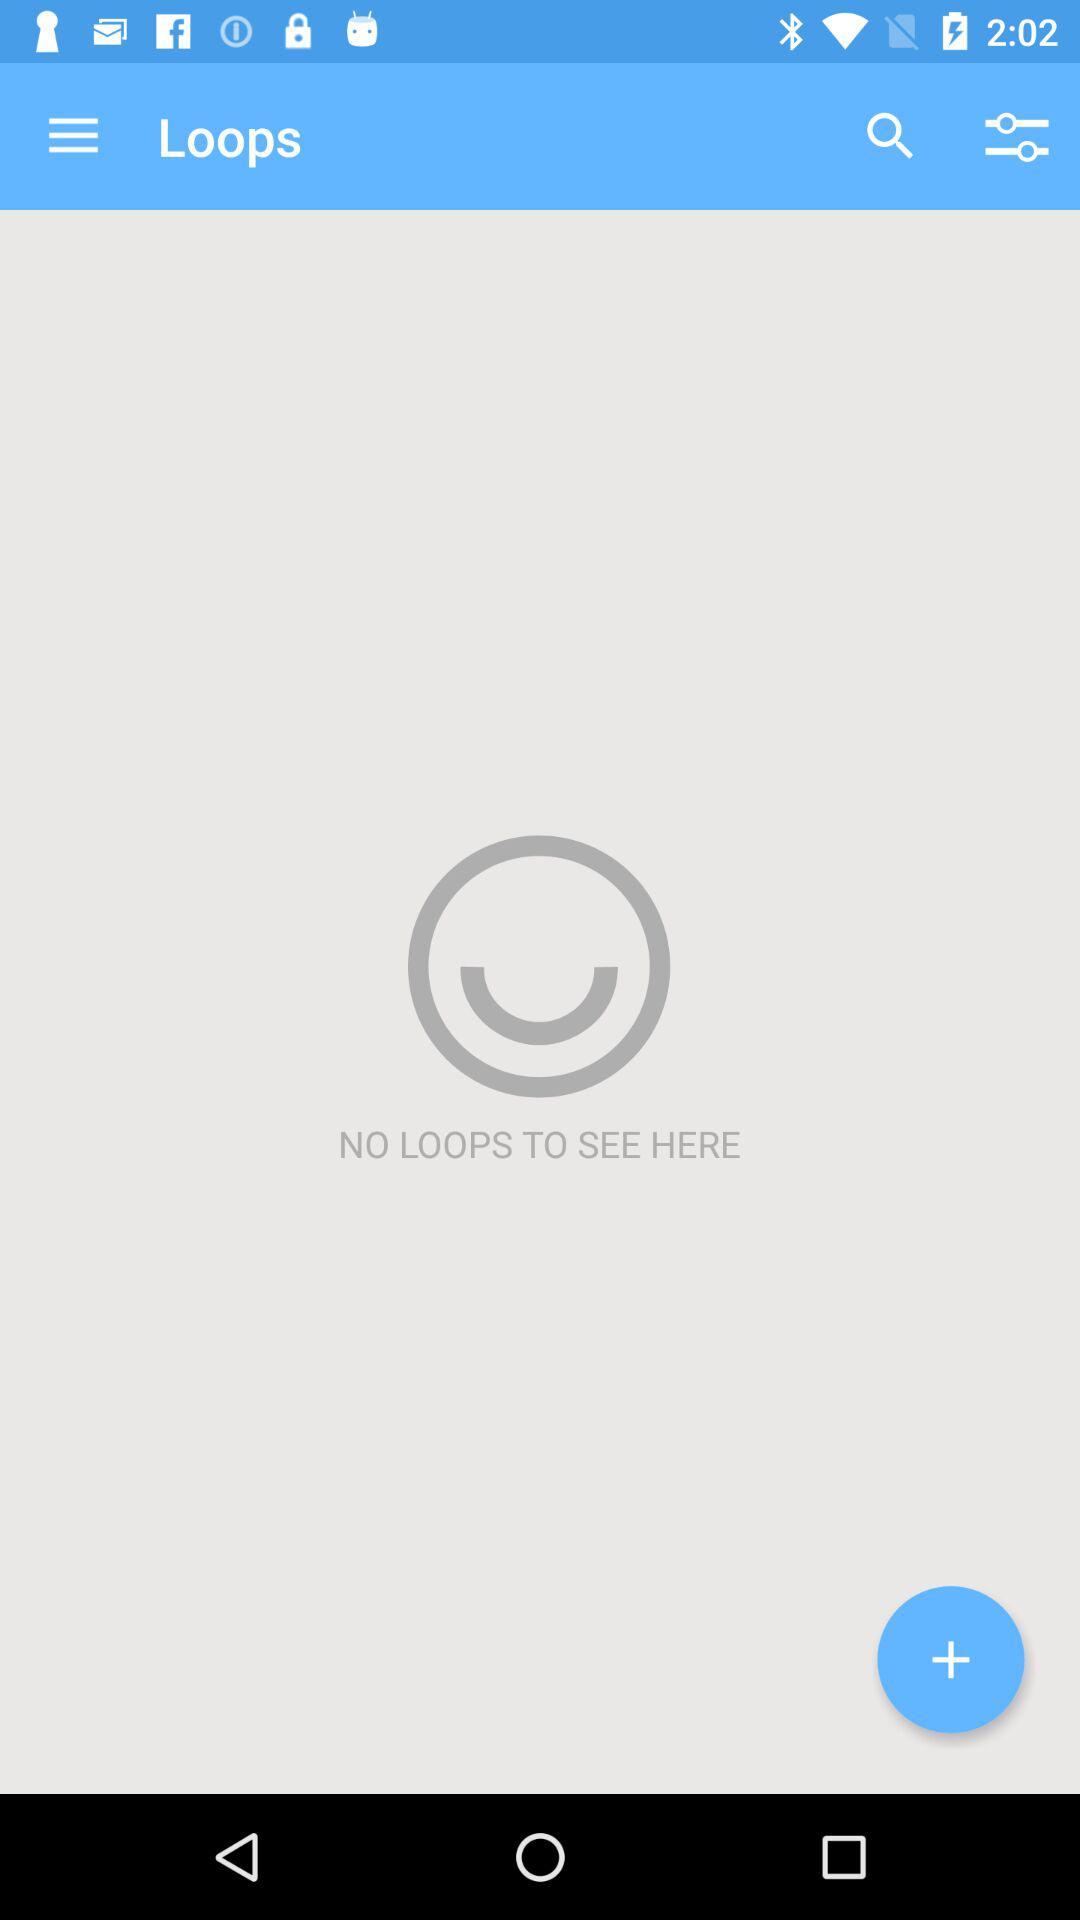Are there any loops? There are no loops. 